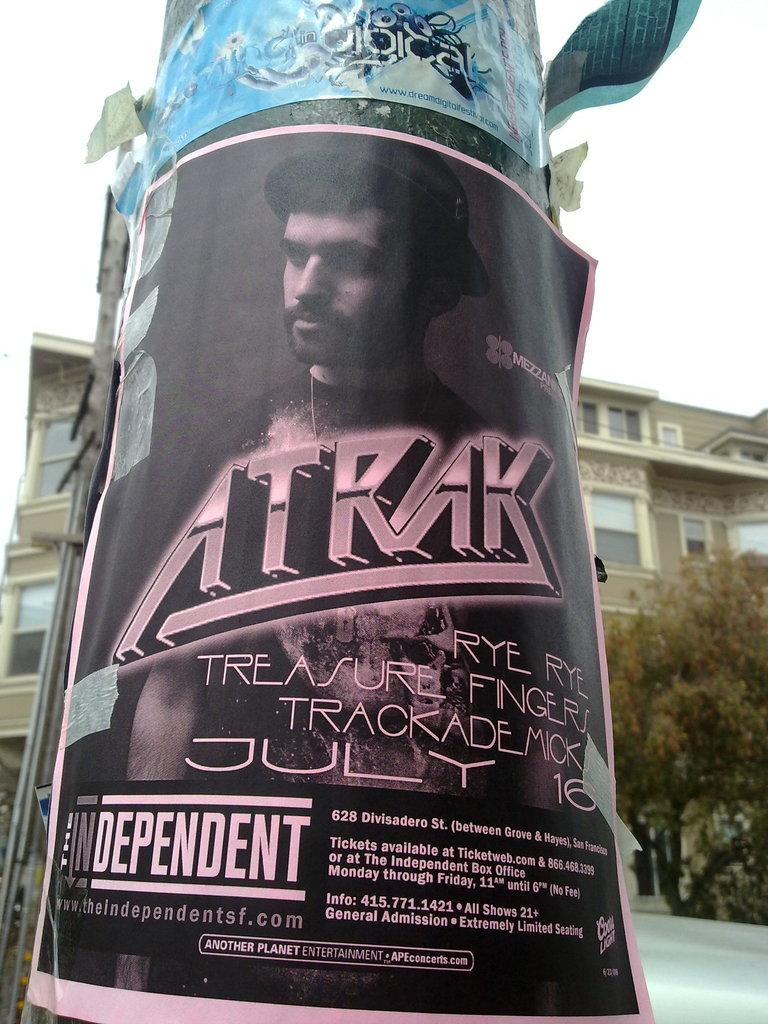What is attached to the pole in the image? There are posters on a pole in the image. What can be seen behind the pole? There is a building and a tree behind the pole. What is visible in the sky in the image? The sky is visible in the image. Are there any other poles in the image? Yes, there is another pole on the left side of the image. Can you see a flock of birds flying near the moon in the image? There is no flock of birds or moon present in the image. 